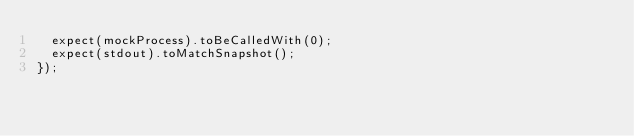Convert code to text. <code><loc_0><loc_0><loc_500><loc_500><_TypeScript_>  expect(mockProcess).toBeCalledWith(0);
  expect(stdout).toMatchSnapshot();
});
</code> 